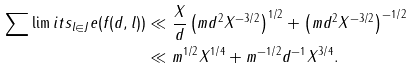Convert formula to latex. <formula><loc_0><loc_0><loc_500><loc_500>\sum \lim i t s _ { l \in J } e ( f ( d , l ) ) & \ll \frac { X } { d } \left ( m d ^ { 2 } X ^ { - 3 / 2 } \right ) ^ { 1 / 2 } + \left ( m d ^ { 2 } X ^ { - 3 / 2 } \right ) ^ { - 1 / 2 } \\ & \ll m ^ { 1 / 2 } X ^ { 1 / 4 } + m ^ { - 1 / 2 } d ^ { - 1 } X ^ { 3 / 4 } .</formula> 